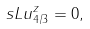<formula> <loc_0><loc_0><loc_500><loc_500>\ s L u ^ { z } _ { 4 / 3 } = 0 ,</formula> 